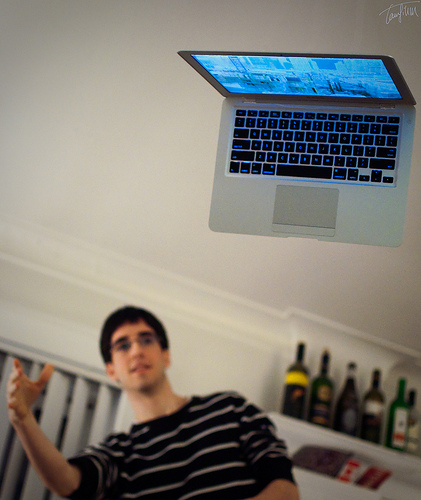<image>
Is there a laptop on the man? No. The laptop is not positioned on the man. They may be near each other, but the laptop is not supported by or resting on top of the man. Is the laptop in front of the man? Yes. The laptop is positioned in front of the man, appearing closer to the camera viewpoint. Where is the man in relation to the wine bottle? Is it to the left of the wine bottle? Yes. From this viewpoint, the man is positioned to the left side relative to the wine bottle. 